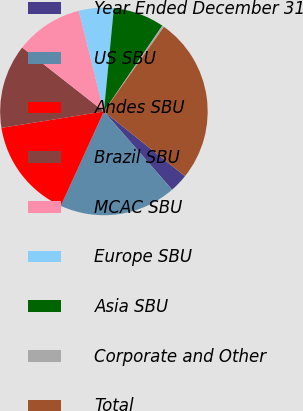Convert chart to OTSL. <chart><loc_0><loc_0><loc_500><loc_500><pie_chart><fcel>Year Ended December 31<fcel>US SBU<fcel>Andes SBU<fcel>Brazil SBU<fcel>MCAC SBU<fcel>Europe SBU<fcel>Asia SBU<fcel>Corporate and Other<fcel>Total<nl><fcel>2.87%<fcel>18.22%<fcel>15.66%<fcel>13.1%<fcel>10.54%<fcel>5.42%<fcel>7.98%<fcel>0.31%<fcel>25.9%<nl></chart> 